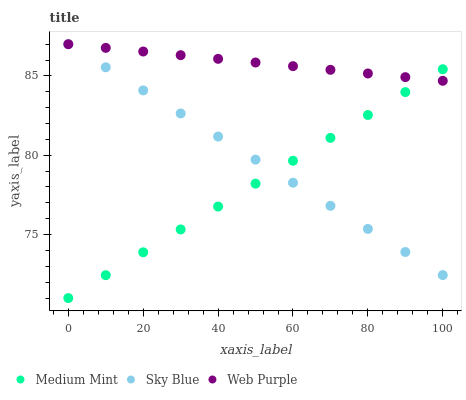Does Medium Mint have the minimum area under the curve?
Answer yes or no. Yes. Does Web Purple have the maximum area under the curve?
Answer yes or no. Yes. Does Sky Blue have the minimum area under the curve?
Answer yes or no. No. Does Sky Blue have the maximum area under the curve?
Answer yes or no. No. Is Medium Mint the smoothest?
Answer yes or no. Yes. Is Web Purple the roughest?
Answer yes or no. Yes. Is Sky Blue the smoothest?
Answer yes or no. No. Is Sky Blue the roughest?
Answer yes or no. No. Does Medium Mint have the lowest value?
Answer yes or no. Yes. Does Sky Blue have the lowest value?
Answer yes or no. No. Does Web Purple have the highest value?
Answer yes or no. Yes. Does Medium Mint intersect Web Purple?
Answer yes or no. Yes. Is Medium Mint less than Web Purple?
Answer yes or no. No. Is Medium Mint greater than Web Purple?
Answer yes or no. No. 